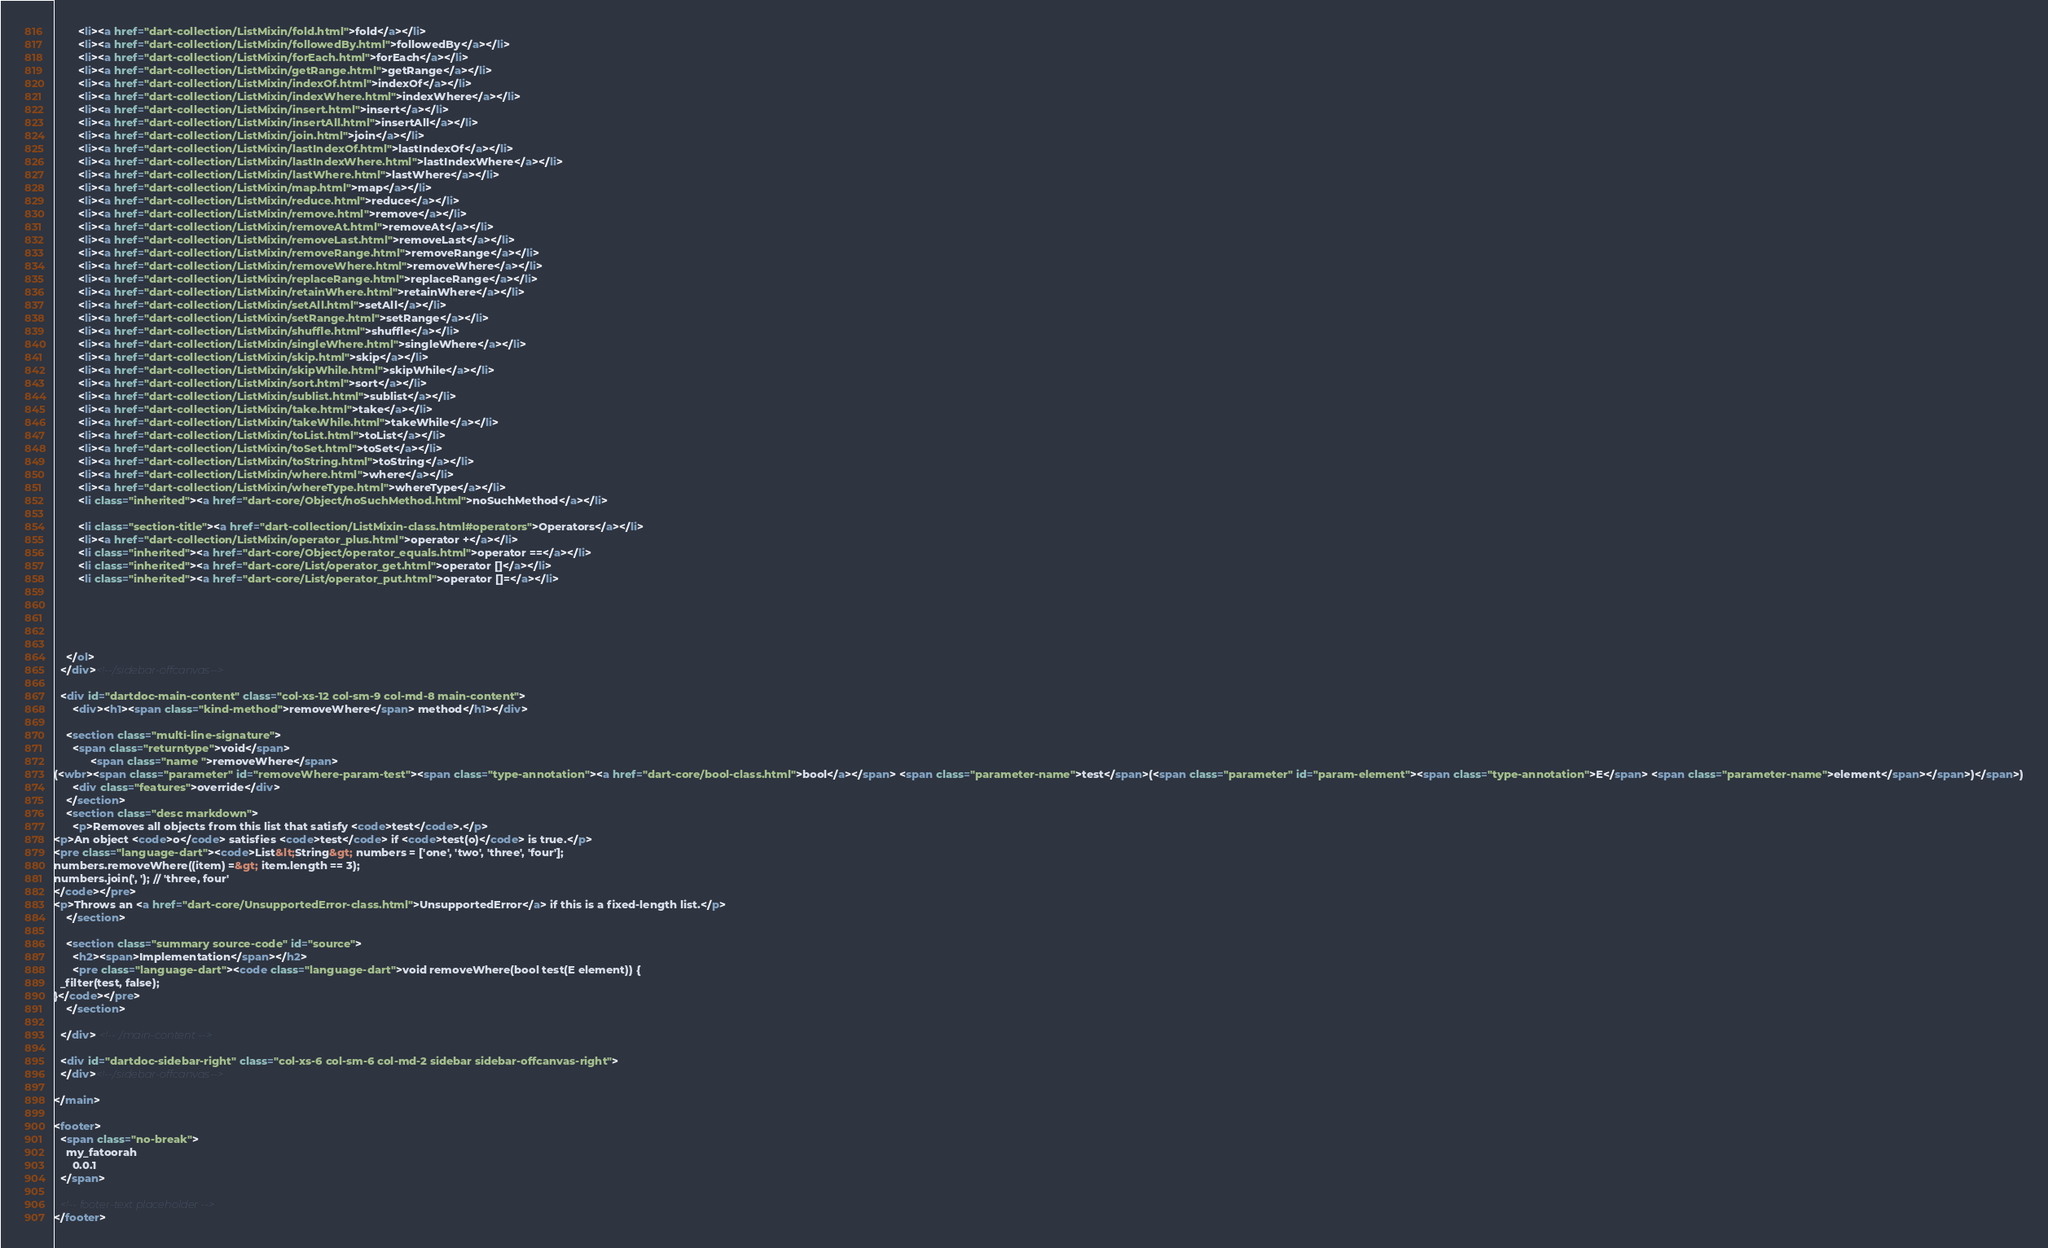<code> <loc_0><loc_0><loc_500><loc_500><_HTML_>        <li><a href="dart-collection/ListMixin/fold.html">fold</a></li>
        <li><a href="dart-collection/ListMixin/followedBy.html">followedBy</a></li>
        <li><a href="dart-collection/ListMixin/forEach.html">forEach</a></li>
        <li><a href="dart-collection/ListMixin/getRange.html">getRange</a></li>
        <li><a href="dart-collection/ListMixin/indexOf.html">indexOf</a></li>
        <li><a href="dart-collection/ListMixin/indexWhere.html">indexWhere</a></li>
        <li><a href="dart-collection/ListMixin/insert.html">insert</a></li>
        <li><a href="dart-collection/ListMixin/insertAll.html">insertAll</a></li>
        <li><a href="dart-collection/ListMixin/join.html">join</a></li>
        <li><a href="dart-collection/ListMixin/lastIndexOf.html">lastIndexOf</a></li>
        <li><a href="dart-collection/ListMixin/lastIndexWhere.html">lastIndexWhere</a></li>
        <li><a href="dart-collection/ListMixin/lastWhere.html">lastWhere</a></li>
        <li><a href="dart-collection/ListMixin/map.html">map</a></li>
        <li><a href="dart-collection/ListMixin/reduce.html">reduce</a></li>
        <li><a href="dart-collection/ListMixin/remove.html">remove</a></li>
        <li><a href="dart-collection/ListMixin/removeAt.html">removeAt</a></li>
        <li><a href="dart-collection/ListMixin/removeLast.html">removeLast</a></li>
        <li><a href="dart-collection/ListMixin/removeRange.html">removeRange</a></li>
        <li><a href="dart-collection/ListMixin/removeWhere.html">removeWhere</a></li>
        <li><a href="dart-collection/ListMixin/replaceRange.html">replaceRange</a></li>
        <li><a href="dart-collection/ListMixin/retainWhere.html">retainWhere</a></li>
        <li><a href="dart-collection/ListMixin/setAll.html">setAll</a></li>
        <li><a href="dart-collection/ListMixin/setRange.html">setRange</a></li>
        <li><a href="dart-collection/ListMixin/shuffle.html">shuffle</a></li>
        <li><a href="dart-collection/ListMixin/singleWhere.html">singleWhere</a></li>
        <li><a href="dart-collection/ListMixin/skip.html">skip</a></li>
        <li><a href="dart-collection/ListMixin/skipWhile.html">skipWhile</a></li>
        <li><a href="dart-collection/ListMixin/sort.html">sort</a></li>
        <li><a href="dart-collection/ListMixin/sublist.html">sublist</a></li>
        <li><a href="dart-collection/ListMixin/take.html">take</a></li>
        <li><a href="dart-collection/ListMixin/takeWhile.html">takeWhile</a></li>
        <li><a href="dart-collection/ListMixin/toList.html">toList</a></li>
        <li><a href="dart-collection/ListMixin/toSet.html">toSet</a></li>
        <li><a href="dart-collection/ListMixin/toString.html">toString</a></li>
        <li><a href="dart-collection/ListMixin/where.html">where</a></li>
        <li><a href="dart-collection/ListMixin/whereType.html">whereType</a></li>
        <li class="inherited"><a href="dart-core/Object/noSuchMethod.html">noSuchMethod</a></li>
    
        <li class="section-title"><a href="dart-collection/ListMixin-class.html#operators">Operators</a></li>
        <li><a href="dart-collection/ListMixin/operator_plus.html">operator +</a></li>
        <li class="inherited"><a href="dart-core/Object/operator_equals.html">operator ==</a></li>
        <li class="inherited"><a href="dart-core/List/operator_get.html">operator []</a></li>
        <li class="inherited"><a href="dart-core/List/operator_put.html">operator []=</a></li>
    
    
    
    
    
    </ol>
  </div><!--/.sidebar-offcanvas-->

  <div id="dartdoc-main-content" class="col-xs-12 col-sm-9 col-md-8 main-content">
      <div><h1><span class="kind-method">removeWhere</span> method</h1></div>

    <section class="multi-line-signature">
      <span class="returntype">void</span>
            <span class="name ">removeWhere</span>
(<wbr><span class="parameter" id="removeWhere-param-test"><span class="type-annotation"><a href="dart-core/bool-class.html">bool</a></span> <span class="parameter-name">test</span>(<span class="parameter" id="param-element"><span class="type-annotation">E</span> <span class="parameter-name">element</span></span>)</span>)
      <div class="features">override</div>
    </section>
    <section class="desc markdown">
      <p>Removes all objects from this list that satisfy <code>test</code>.</p>
<p>An object <code>o</code> satisfies <code>test</code> if <code>test(o)</code> is true.</p>
<pre class="language-dart"><code>List&lt;String&gt; numbers = ['one', 'two', 'three', 'four'];
numbers.removeWhere((item) =&gt; item.length == 3);
numbers.join(', '); // 'three, four'
</code></pre>
<p>Throws an <a href="dart-core/UnsupportedError-class.html">UnsupportedError</a> if this is a fixed-length list.</p>
    </section>
    
    <section class="summary source-code" id="source">
      <h2><span>Implementation</span></h2>
      <pre class="language-dart"><code class="language-dart">void removeWhere(bool test(E element)) {
  _filter(test, false);
}</code></pre>
    </section>

  </div> <!-- /.main-content -->

  <div id="dartdoc-sidebar-right" class="col-xs-6 col-sm-6 col-md-2 sidebar sidebar-offcanvas-right">
  </div><!--/.sidebar-offcanvas-->

</main>

<footer>
  <span class="no-break">
    my_fatoorah
      0.0.1
  </span>

  <!-- footer-text placeholder -->
</footer>
</code> 